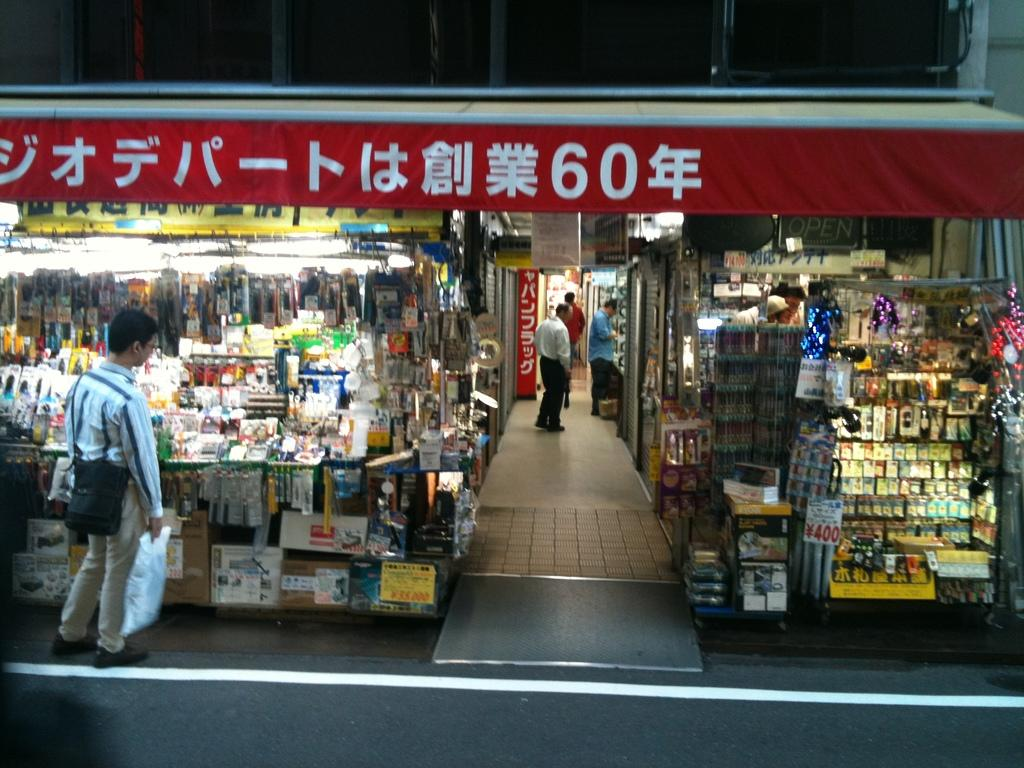<image>
Relay a brief, clear account of the picture shown. A man standing outside of a shopping mart with something written in Chinese on a banner above him including the number 60. 